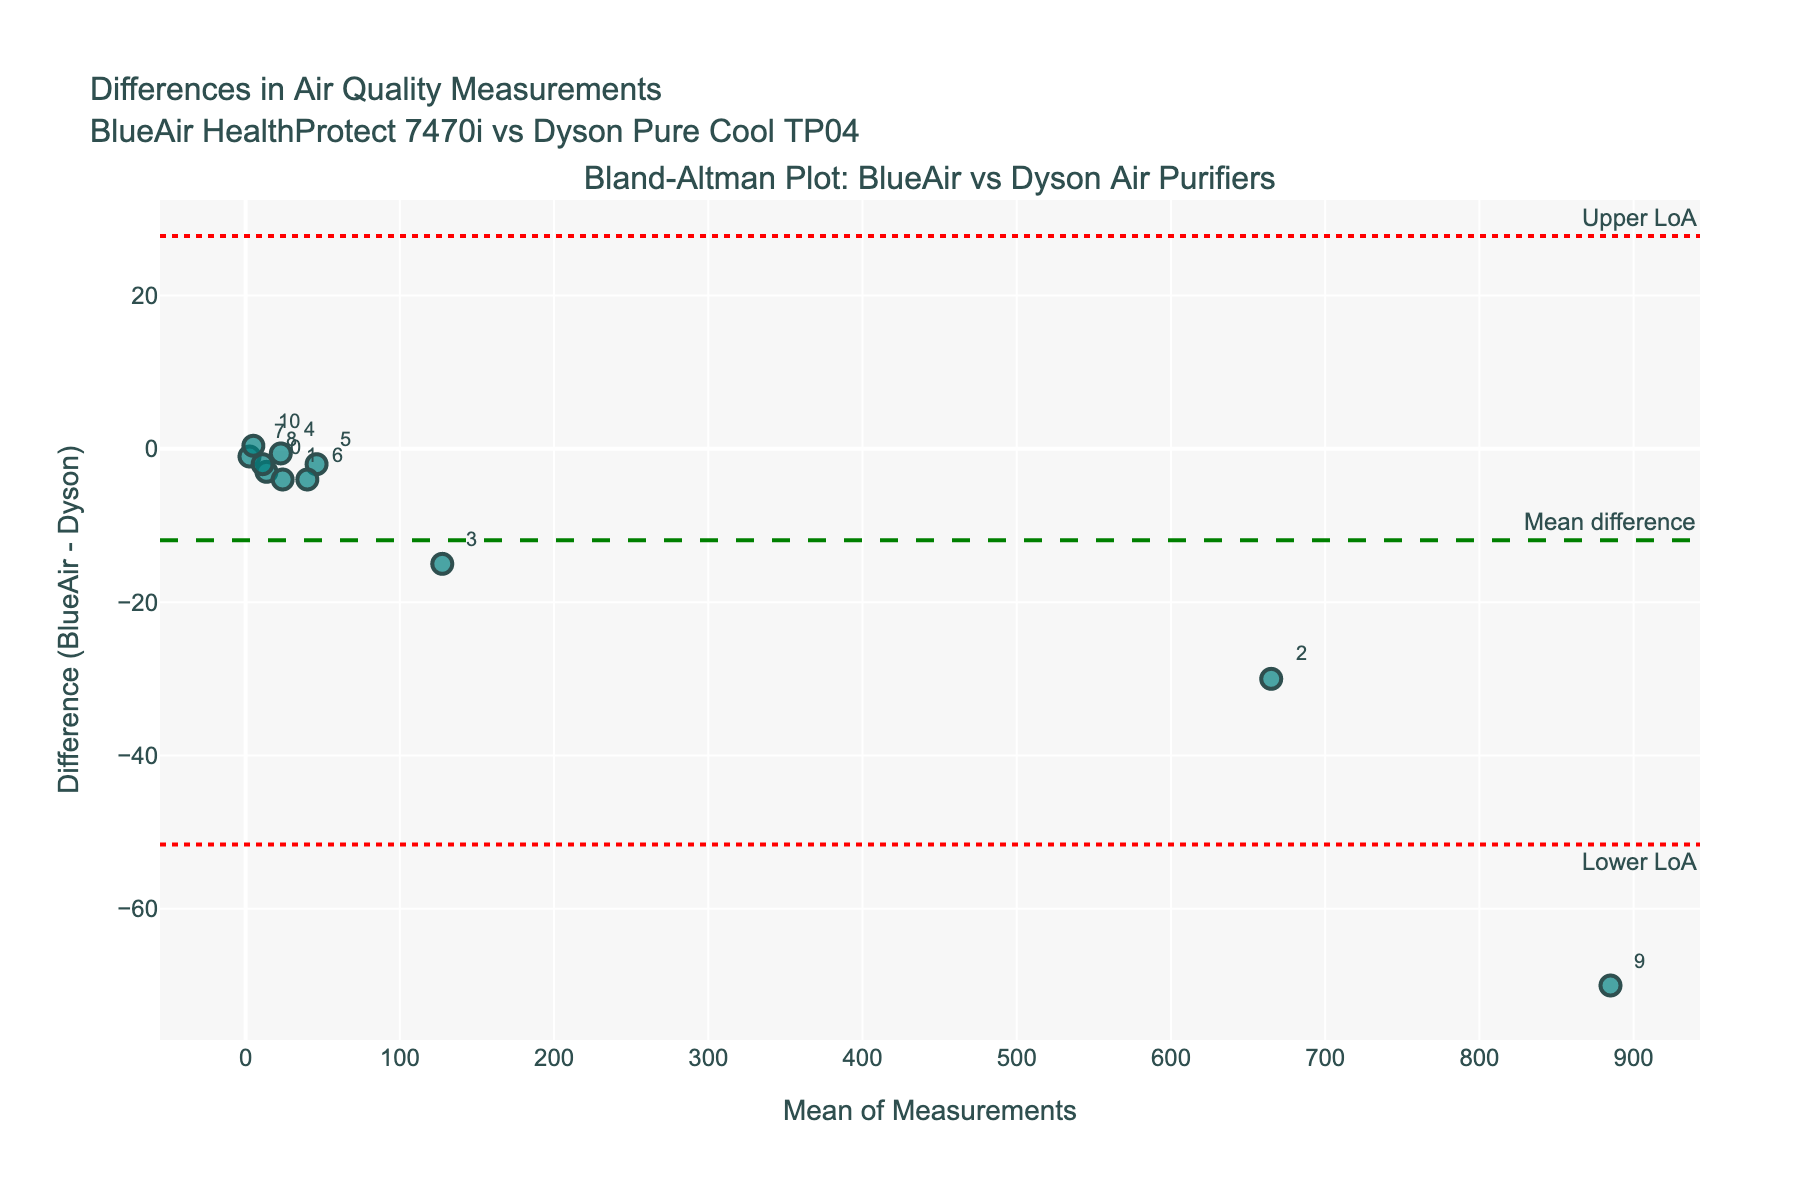What is the title of the Bland-Altman plot? The title is at the top center of the plot and reads "Differences in Air Quality Measurements BlueAir HealthProtect 7470i vs Dyson Pure Cool TP04".
Answer: Differences in Air Quality Measurements BlueAir HealthProtect 7470i vs Dyson Pure Cool TP04 How many data points are plotted on the Bland-Altman plot? The number of data points is given by the number of markers in the plot. There are 10 markers, corresponding to each air quality measurement parameter.
Answer: 10 Which parameter has the highest mean value, and what is it? By examining the data labels on the plot, we can see that "CO2 (ppm)" has the highest mean value among the marked parameters, which is 665 ppm.
Answer: CO2 (ppm), 665 What are the lower and upper limits of agreement in the plot? The plot shows two horizontal dashed lines representing the limits of agreement. The annotations indicate they are "Upper LoA" and "Lower LoA". The actual values are visually aligned with these lines.
Answer: approx. -3.72 and 1.12 What is the mean difference between the two air purifiers? The plot has a horizontal dashed line labeled "Mean difference", which visually aligns with this line.
Answer: approx. -1.3 What does it mean if a data point falls outside the limits of agreement? When a data point falls outside the limits of agreement, it indicates a significant difference between the two air purifier models for that parameter. This suggests that for that particular measurement, one model is not interchangeable with the other.
Answer: Significant difference Which parameter has the largest negative difference, and what is its value? By examining the data labels on the plot, we see that "Formaldehyde (ppb)" has the largest negative difference, which places the marker farthest below the mean difference line.
Answer: Formaldehyde (ppb) What is the range of the differences between BlueAir and Dyson for all parameters? The range is computed from the smallest to the largest difference. The range between the smallest (approx. -7) to the largest (approx. 4).
Answer: approx. -7 to 4 How do you interpret the data point for "Temperature (°C)" in the plot? The position of the marker corresponding to "Temperature (°C)" is close to the mean difference line, indicating only a small difference between the two purifiers for this parameter. It implies the two models have similar performance in controlling temperature.
Answer: Small difference Compare the variability in measurements using BlueAir and Dyson for "PM2.5 (µg/m³)" and "PM10 (µg/m³)". Which one shows a larger discrepancy? The "PM10 (µg/m³)" measurement exhibits a larger discrepancy as its marker is further from the mean difference line compared to "PM2.5 (µg/m³)". This indicates greater variability between the purifier models in PM10 readings.
Answer: PM10 (µg/m³) 